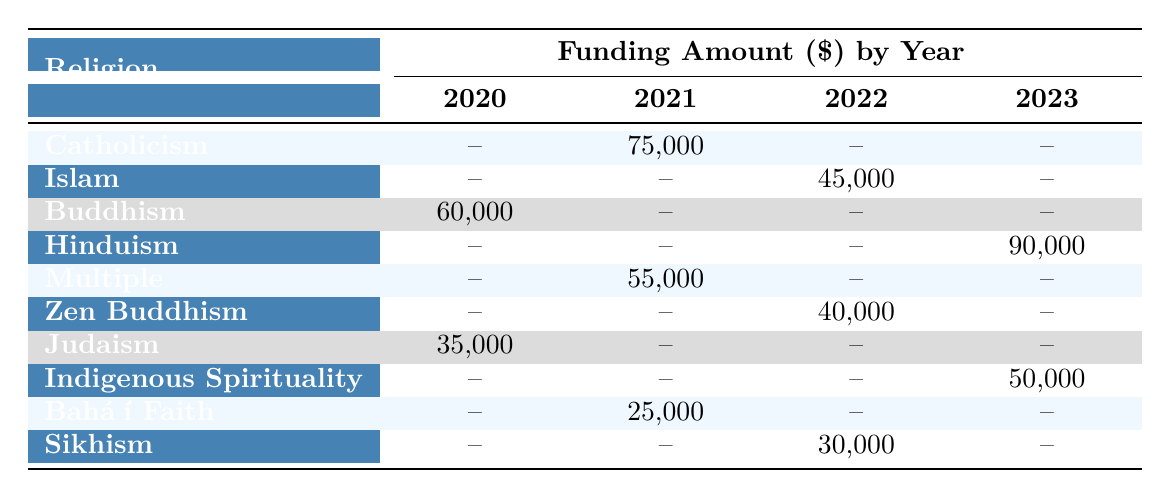What is the funding amount for the Hinduism project in 2023? The table shows that the funding amount for the Hindu Deities Sculpture Garden under Hinduism in 2023 is 90,000.
Answer: 90,000 Which religion has the highest funding amount in 2022? In 2022, the highest funding amount is for the project related to Islam, which received 45,000; Hinduism has a funding amount in 2023, not 2022, so it doesn't count for this year. Islam is the only entry for that year with the highest value.
Answer: Islam Is there any funding listed for Buddhism in 2021? In the table, Buddhism does not list any funding in 2021, as the corresponding cell shows a dash (–) indicating no funding occurred for that year.
Answer: No What is the combined funding amount for Indigenous Spirituality and Sikhism in 2022? For Indigenous Spirituality there is no funding in 2022 (–), and Sikhism received funding of 30,000. Adding these amounts gives 0 + 30,000 = 30,000.
Answer: 30,000 Is the funding from the Vatican Museum shown in the table? Yes, the funding from the Vatican Museum is listed under the project for Catholicism in 2021 with a funding amount of 75,000.
Answer: Yes What is the total amount of funding for all projects in 2020? The total funding amount for 2020 can be calculated by summing the amounts for Buddhism (60,000) and Judaism (35,000), resulting in 60,000 + 35,000 = 95,000.
Answer: 95,000 Which culture received the least funding across all years? The table indicates that the Baháʼí Faith received the least funding amount of 25,000 in 2021, which is lower than any other projects listed.
Answer: Baháʼí Faith Was there any funding provided for a religious project in 2020 without any associated artist listed? According to the table, all projects have an associated artist listed, so there are no entries for 2020 or any other year without an artist.
Answer: No 